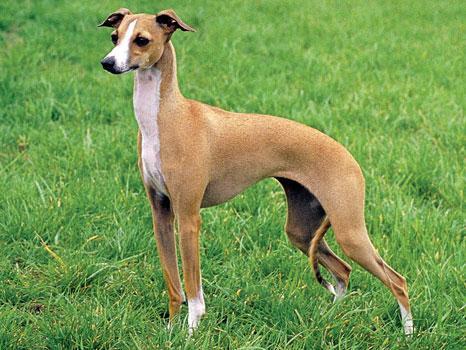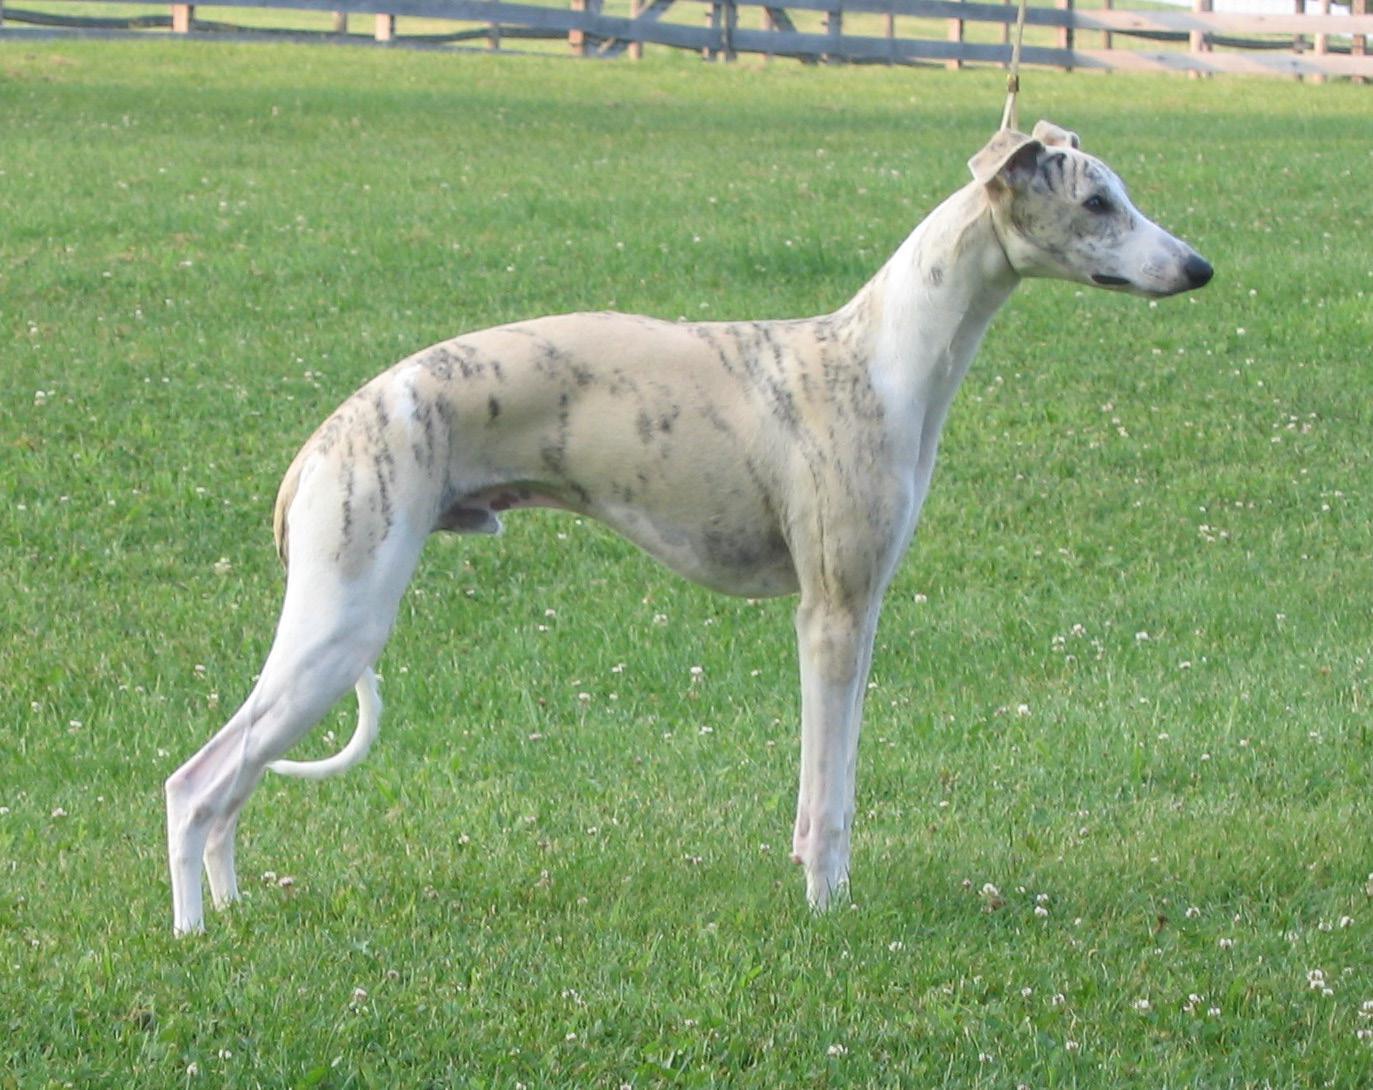The first image is the image on the left, the second image is the image on the right. Assess this claim about the two images: "The right image contains at least two dogs.". Correct or not? Answer yes or no. No. The first image is the image on the left, the second image is the image on the right. Given the left and right images, does the statement "At least one image shows a tan dog with a white chest standing on grass, facing leftward." hold true? Answer yes or no. Yes. 